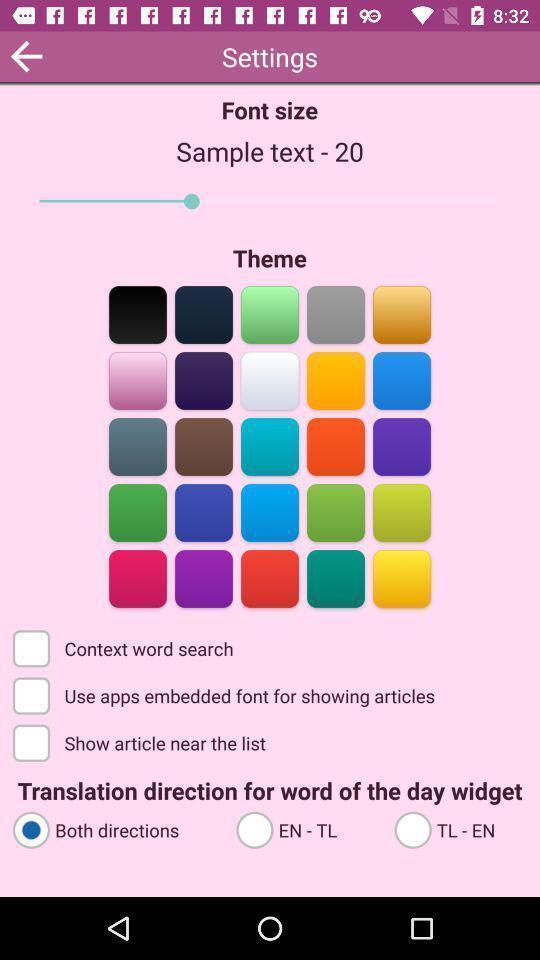What details can you identify in this image? Settings page for editing the background appearance and text. 